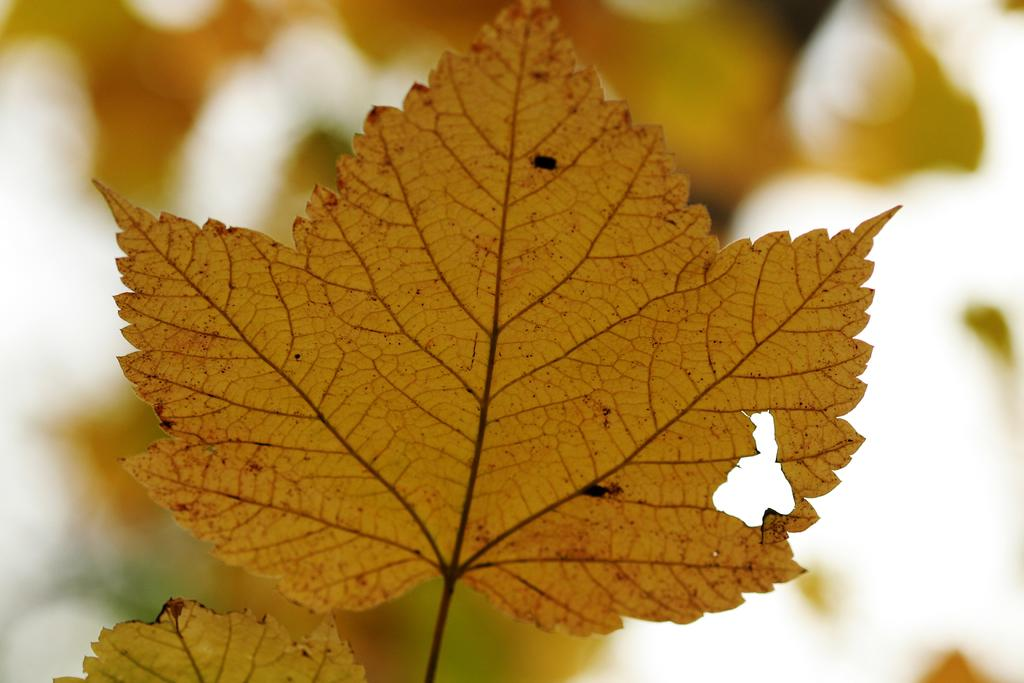What is present in the image? There is a leaf in the image. Can you describe the background of the leaf? The background of the leaf is blurred. What type of furniture can be seen in the image? There is no furniture present in the image; it features a leaf with a blurred background. Is the leaf in motion in the image? The leaf is not in motion in the image; it is stationary. 